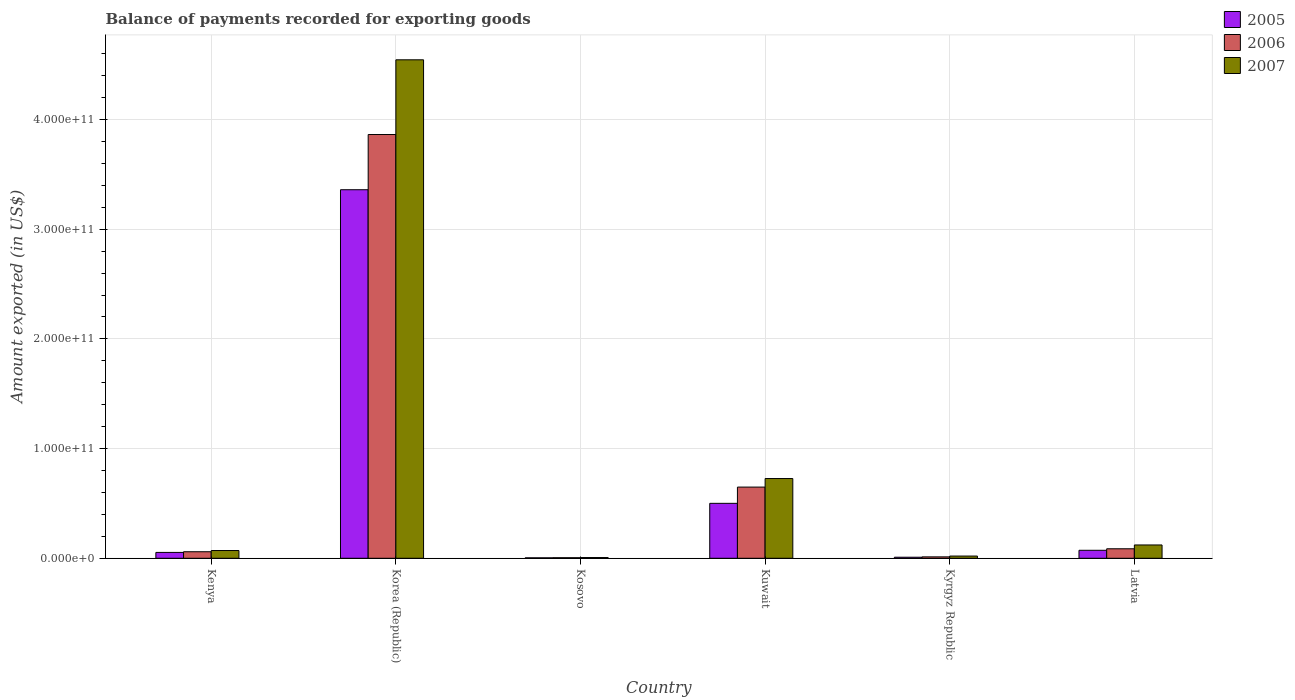How many groups of bars are there?
Your answer should be very brief. 6. How many bars are there on the 1st tick from the left?
Offer a very short reply. 3. What is the label of the 1st group of bars from the left?
Your answer should be compact. Kenya. In how many cases, is the number of bars for a given country not equal to the number of legend labels?
Offer a terse response. 0. What is the amount exported in 2006 in Kyrgyz Republic?
Keep it short and to the point. 1.28e+09. Across all countries, what is the maximum amount exported in 2007?
Your answer should be compact. 4.54e+11. Across all countries, what is the minimum amount exported in 2005?
Your answer should be compact. 4.13e+08. In which country was the amount exported in 2007 maximum?
Your answer should be very brief. Korea (Republic). In which country was the amount exported in 2006 minimum?
Your answer should be very brief. Kosovo. What is the total amount exported in 2006 in the graph?
Provide a succinct answer. 4.68e+11. What is the difference between the amount exported in 2006 in Kosovo and that in Kuwait?
Ensure brevity in your answer.  -6.44e+1. What is the difference between the amount exported in 2006 in Kuwait and the amount exported in 2007 in Korea (Republic)?
Provide a short and direct response. -3.90e+11. What is the average amount exported in 2005 per country?
Offer a terse response. 6.67e+1. What is the difference between the amount exported of/in 2005 and amount exported of/in 2006 in Kenya?
Provide a short and direct response. -6.04e+08. In how many countries, is the amount exported in 2006 greater than 40000000000 US$?
Make the answer very short. 2. What is the ratio of the amount exported in 2006 in Kenya to that in Kuwait?
Offer a very short reply. 0.09. Is the amount exported in 2006 in Kenya less than that in Latvia?
Your answer should be compact. Yes. What is the difference between the highest and the second highest amount exported in 2006?
Give a very brief answer. 3.21e+11. What is the difference between the highest and the lowest amount exported in 2005?
Make the answer very short. 3.36e+11. How many bars are there?
Make the answer very short. 18. How many countries are there in the graph?
Give a very brief answer. 6. What is the difference between two consecutive major ticks on the Y-axis?
Ensure brevity in your answer.  1.00e+11. Are the values on the major ticks of Y-axis written in scientific E-notation?
Your answer should be compact. Yes. Where does the legend appear in the graph?
Your response must be concise. Top right. How are the legend labels stacked?
Your response must be concise. Vertical. What is the title of the graph?
Your response must be concise. Balance of payments recorded for exporting goods. What is the label or title of the X-axis?
Your answer should be compact. Country. What is the label or title of the Y-axis?
Your response must be concise. Amount exported (in US$). What is the Amount exported (in US$) in 2005 in Kenya?
Offer a very short reply. 5.34e+09. What is the Amount exported (in US$) of 2006 in Kenya?
Ensure brevity in your answer.  5.95e+09. What is the Amount exported (in US$) of 2007 in Kenya?
Offer a terse response. 7.06e+09. What is the Amount exported (in US$) in 2005 in Korea (Republic)?
Your response must be concise. 3.36e+11. What is the Amount exported (in US$) of 2006 in Korea (Republic)?
Ensure brevity in your answer.  3.86e+11. What is the Amount exported (in US$) in 2007 in Korea (Republic)?
Give a very brief answer. 4.54e+11. What is the Amount exported (in US$) in 2005 in Kosovo?
Make the answer very short. 4.13e+08. What is the Amount exported (in US$) in 2006 in Kosovo?
Give a very brief answer. 5.15e+08. What is the Amount exported (in US$) of 2007 in Kosovo?
Your answer should be compact. 6.68e+08. What is the Amount exported (in US$) of 2005 in Kuwait?
Provide a succinct answer. 5.01e+1. What is the Amount exported (in US$) of 2006 in Kuwait?
Offer a very short reply. 6.49e+1. What is the Amount exported (in US$) in 2007 in Kuwait?
Your answer should be compact. 7.27e+1. What is the Amount exported (in US$) of 2005 in Kyrgyz Republic?
Provide a succinct answer. 9.46e+08. What is the Amount exported (in US$) of 2006 in Kyrgyz Republic?
Your response must be concise. 1.28e+09. What is the Amount exported (in US$) in 2007 in Kyrgyz Republic?
Give a very brief answer. 2.02e+09. What is the Amount exported (in US$) in 2005 in Latvia?
Offer a very short reply. 7.27e+09. What is the Amount exported (in US$) of 2006 in Latvia?
Offer a very short reply. 8.65e+09. What is the Amount exported (in US$) of 2007 in Latvia?
Offer a terse response. 1.21e+1. Across all countries, what is the maximum Amount exported (in US$) of 2005?
Provide a short and direct response. 3.36e+11. Across all countries, what is the maximum Amount exported (in US$) in 2006?
Your answer should be compact. 3.86e+11. Across all countries, what is the maximum Amount exported (in US$) of 2007?
Your answer should be compact. 4.54e+11. Across all countries, what is the minimum Amount exported (in US$) of 2005?
Your response must be concise. 4.13e+08. Across all countries, what is the minimum Amount exported (in US$) of 2006?
Make the answer very short. 5.15e+08. Across all countries, what is the minimum Amount exported (in US$) in 2007?
Your response must be concise. 6.68e+08. What is the total Amount exported (in US$) in 2005 in the graph?
Your response must be concise. 4.00e+11. What is the total Amount exported (in US$) in 2006 in the graph?
Provide a succinct answer. 4.68e+11. What is the total Amount exported (in US$) of 2007 in the graph?
Give a very brief answer. 5.49e+11. What is the difference between the Amount exported (in US$) of 2005 in Kenya and that in Korea (Republic)?
Offer a very short reply. -3.31e+11. What is the difference between the Amount exported (in US$) of 2006 in Kenya and that in Korea (Republic)?
Keep it short and to the point. -3.80e+11. What is the difference between the Amount exported (in US$) in 2007 in Kenya and that in Korea (Republic)?
Provide a short and direct response. -4.47e+11. What is the difference between the Amount exported (in US$) in 2005 in Kenya and that in Kosovo?
Make the answer very short. 4.93e+09. What is the difference between the Amount exported (in US$) in 2006 in Kenya and that in Kosovo?
Make the answer very short. 5.43e+09. What is the difference between the Amount exported (in US$) of 2007 in Kenya and that in Kosovo?
Ensure brevity in your answer.  6.39e+09. What is the difference between the Amount exported (in US$) of 2005 in Kenya and that in Kuwait?
Offer a very short reply. -4.47e+1. What is the difference between the Amount exported (in US$) in 2006 in Kenya and that in Kuwait?
Make the answer very short. -5.90e+1. What is the difference between the Amount exported (in US$) of 2007 in Kenya and that in Kuwait?
Your answer should be very brief. -6.56e+1. What is the difference between the Amount exported (in US$) in 2005 in Kenya and that in Kyrgyz Republic?
Provide a short and direct response. 4.40e+09. What is the difference between the Amount exported (in US$) in 2006 in Kenya and that in Kyrgyz Republic?
Give a very brief answer. 4.66e+09. What is the difference between the Amount exported (in US$) of 2007 in Kenya and that in Kyrgyz Republic?
Your response must be concise. 5.04e+09. What is the difference between the Amount exported (in US$) of 2005 in Kenya and that in Latvia?
Ensure brevity in your answer.  -1.93e+09. What is the difference between the Amount exported (in US$) of 2006 in Kenya and that in Latvia?
Make the answer very short. -2.71e+09. What is the difference between the Amount exported (in US$) of 2007 in Kenya and that in Latvia?
Your answer should be compact. -5.07e+09. What is the difference between the Amount exported (in US$) in 2005 in Korea (Republic) and that in Kosovo?
Your response must be concise. 3.36e+11. What is the difference between the Amount exported (in US$) of 2006 in Korea (Republic) and that in Kosovo?
Offer a terse response. 3.86e+11. What is the difference between the Amount exported (in US$) of 2007 in Korea (Republic) and that in Kosovo?
Offer a very short reply. 4.54e+11. What is the difference between the Amount exported (in US$) of 2005 in Korea (Republic) and that in Kuwait?
Provide a succinct answer. 2.86e+11. What is the difference between the Amount exported (in US$) of 2006 in Korea (Republic) and that in Kuwait?
Your response must be concise. 3.21e+11. What is the difference between the Amount exported (in US$) of 2007 in Korea (Republic) and that in Kuwait?
Make the answer very short. 3.82e+11. What is the difference between the Amount exported (in US$) of 2005 in Korea (Republic) and that in Kyrgyz Republic?
Provide a short and direct response. 3.35e+11. What is the difference between the Amount exported (in US$) in 2006 in Korea (Republic) and that in Kyrgyz Republic?
Your answer should be compact. 3.85e+11. What is the difference between the Amount exported (in US$) in 2007 in Korea (Republic) and that in Kyrgyz Republic?
Keep it short and to the point. 4.52e+11. What is the difference between the Amount exported (in US$) of 2005 in Korea (Republic) and that in Latvia?
Provide a short and direct response. 3.29e+11. What is the difference between the Amount exported (in US$) of 2006 in Korea (Republic) and that in Latvia?
Provide a short and direct response. 3.78e+11. What is the difference between the Amount exported (in US$) in 2007 in Korea (Republic) and that in Latvia?
Provide a succinct answer. 4.42e+11. What is the difference between the Amount exported (in US$) in 2005 in Kosovo and that in Kuwait?
Provide a succinct answer. -4.97e+1. What is the difference between the Amount exported (in US$) of 2006 in Kosovo and that in Kuwait?
Offer a very short reply. -6.44e+1. What is the difference between the Amount exported (in US$) of 2007 in Kosovo and that in Kuwait?
Offer a terse response. -7.20e+1. What is the difference between the Amount exported (in US$) of 2005 in Kosovo and that in Kyrgyz Republic?
Offer a terse response. -5.33e+08. What is the difference between the Amount exported (in US$) of 2006 in Kosovo and that in Kyrgyz Republic?
Keep it short and to the point. -7.70e+08. What is the difference between the Amount exported (in US$) in 2007 in Kosovo and that in Kyrgyz Republic?
Offer a terse response. -1.35e+09. What is the difference between the Amount exported (in US$) of 2005 in Kosovo and that in Latvia?
Provide a succinct answer. -6.86e+09. What is the difference between the Amount exported (in US$) of 2006 in Kosovo and that in Latvia?
Provide a succinct answer. -8.14e+09. What is the difference between the Amount exported (in US$) in 2007 in Kosovo and that in Latvia?
Provide a short and direct response. -1.15e+1. What is the difference between the Amount exported (in US$) of 2005 in Kuwait and that in Kyrgyz Republic?
Keep it short and to the point. 4.91e+1. What is the difference between the Amount exported (in US$) of 2006 in Kuwait and that in Kyrgyz Republic?
Ensure brevity in your answer.  6.36e+1. What is the difference between the Amount exported (in US$) of 2007 in Kuwait and that in Kyrgyz Republic?
Provide a succinct answer. 7.07e+1. What is the difference between the Amount exported (in US$) of 2005 in Kuwait and that in Latvia?
Keep it short and to the point. 4.28e+1. What is the difference between the Amount exported (in US$) in 2006 in Kuwait and that in Latvia?
Your answer should be very brief. 5.62e+1. What is the difference between the Amount exported (in US$) of 2007 in Kuwait and that in Latvia?
Make the answer very short. 6.06e+1. What is the difference between the Amount exported (in US$) in 2005 in Kyrgyz Republic and that in Latvia?
Keep it short and to the point. -6.33e+09. What is the difference between the Amount exported (in US$) in 2006 in Kyrgyz Republic and that in Latvia?
Provide a succinct answer. -7.37e+09. What is the difference between the Amount exported (in US$) in 2007 in Kyrgyz Republic and that in Latvia?
Provide a short and direct response. -1.01e+1. What is the difference between the Amount exported (in US$) of 2005 in Kenya and the Amount exported (in US$) of 2006 in Korea (Republic)?
Keep it short and to the point. -3.81e+11. What is the difference between the Amount exported (in US$) of 2005 in Kenya and the Amount exported (in US$) of 2007 in Korea (Republic)?
Keep it short and to the point. -4.49e+11. What is the difference between the Amount exported (in US$) of 2006 in Kenya and the Amount exported (in US$) of 2007 in Korea (Republic)?
Keep it short and to the point. -4.48e+11. What is the difference between the Amount exported (in US$) of 2005 in Kenya and the Amount exported (in US$) of 2006 in Kosovo?
Offer a very short reply. 4.83e+09. What is the difference between the Amount exported (in US$) of 2005 in Kenya and the Amount exported (in US$) of 2007 in Kosovo?
Give a very brief answer. 4.67e+09. What is the difference between the Amount exported (in US$) in 2006 in Kenya and the Amount exported (in US$) in 2007 in Kosovo?
Provide a succinct answer. 5.28e+09. What is the difference between the Amount exported (in US$) of 2005 in Kenya and the Amount exported (in US$) of 2006 in Kuwait?
Keep it short and to the point. -5.96e+1. What is the difference between the Amount exported (in US$) in 2005 in Kenya and the Amount exported (in US$) in 2007 in Kuwait?
Your response must be concise. -6.74e+1. What is the difference between the Amount exported (in US$) of 2006 in Kenya and the Amount exported (in US$) of 2007 in Kuwait?
Your answer should be compact. -6.67e+1. What is the difference between the Amount exported (in US$) of 2005 in Kenya and the Amount exported (in US$) of 2006 in Kyrgyz Republic?
Provide a short and direct response. 4.06e+09. What is the difference between the Amount exported (in US$) of 2005 in Kenya and the Amount exported (in US$) of 2007 in Kyrgyz Republic?
Make the answer very short. 3.32e+09. What is the difference between the Amount exported (in US$) in 2006 in Kenya and the Amount exported (in US$) in 2007 in Kyrgyz Republic?
Provide a short and direct response. 3.92e+09. What is the difference between the Amount exported (in US$) in 2005 in Kenya and the Amount exported (in US$) in 2006 in Latvia?
Provide a succinct answer. -3.31e+09. What is the difference between the Amount exported (in US$) in 2005 in Kenya and the Amount exported (in US$) in 2007 in Latvia?
Give a very brief answer. -6.80e+09. What is the difference between the Amount exported (in US$) in 2006 in Kenya and the Amount exported (in US$) in 2007 in Latvia?
Offer a terse response. -6.19e+09. What is the difference between the Amount exported (in US$) of 2005 in Korea (Republic) and the Amount exported (in US$) of 2006 in Kosovo?
Your answer should be compact. 3.35e+11. What is the difference between the Amount exported (in US$) of 2005 in Korea (Republic) and the Amount exported (in US$) of 2007 in Kosovo?
Offer a very short reply. 3.35e+11. What is the difference between the Amount exported (in US$) of 2006 in Korea (Republic) and the Amount exported (in US$) of 2007 in Kosovo?
Make the answer very short. 3.86e+11. What is the difference between the Amount exported (in US$) of 2005 in Korea (Republic) and the Amount exported (in US$) of 2006 in Kuwait?
Provide a short and direct response. 2.71e+11. What is the difference between the Amount exported (in US$) in 2005 in Korea (Republic) and the Amount exported (in US$) in 2007 in Kuwait?
Your response must be concise. 2.63e+11. What is the difference between the Amount exported (in US$) of 2006 in Korea (Republic) and the Amount exported (in US$) of 2007 in Kuwait?
Keep it short and to the point. 3.14e+11. What is the difference between the Amount exported (in US$) of 2005 in Korea (Republic) and the Amount exported (in US$) of 2006 in Kyrgyz Republic?
Your answer should be very brief. 3.35e+11. What is the difference between the Amount exported (in US$) in 2005 in Korea (Republic) and the Amount exported (in US$) in 2007 in Kyrgyz Republic?
Provide a short and direct response. 3.34e+11. What is the difference between the Amount exported (in US$) of 2006 in Korea (Republic) and the Amount exported (in US$) of 2007 in Kyrgyz Republic?
Your response must be concise. 3.84e+11. What is the difference between the Amount exported (in US$) of 2005 in Korea (Republic) and the Amount exported (in US$) of 2006 in Latvia?
Ensure brevity in your answer.  3.27e+11. What is the difference between the Amount exported (in US$) of 2005 in Korea (Republic) and the Amount exported (in US$) of 2007 in Latvia?
Keep it short and to the point. 3.24e+11. What is the difference between the Amount exported (in US$) of 2006 in Korea (Republic) and the Amount exported (in US$) of 2007 in Latvia?
Provide a succinct answer. 3.74e+11. What is the difference between the Amount exported (in US$) of 2005 in Kosovo and the Amount exported (in US$) of 2006 in Kuwait?
Make the answer very short. -6.45e+1. What is the difference between the Amount exported (in US$) in 2005 in Kosovo and the Amount exported (in US$) in 2007 in Kuwait?
Your response must be concise. -7.23e+1. What is the difference between the Amount exported (in US$) in 2006 in Kosovo and the Amount exported (in US$) in 2007 in Kuwait?
Offer a terse response. -7.22e+1. What is the difference between the Amount exported (in US$) in 2005 in Kosovo and the Amount exported (in US$) in 2006 in Kyrgyz Republic?
Provide a short and direct response. -8.72e+08. What is the difference between the Amount exported (in US$) in 2005 in Kosovo and the Amount exported (in US$) in 2007 in Kyrgyz Republic?
Offer a terse response. -1.61e+09. What is the difference between the Amount exported (in US$) of 2006 in Kosovo and the Amount exported (in US$) of 2007 in Kyrgyz Republic?
Give a very brief answer. -1.51e+09. What is the difference between the Amount exported (in US$) of 2005 in Kosovo and the Amount exported (in US$) of 2006 in Latvia?
Provide a succinct answer. -8.24e+09. What is the difference between the Amount exported (in US$) in 2005 in Kosovo and the Amount exported (in US$) in 2007 in Latvia?
Provide a succinct answer. -1.17e+1. What is the difference between the Amount exported (in US$) of 2006 in Kosovo and the Amount exported (in US$) of 2007 in Latvia?
Give a very brief answer. -1.16e+1. What is the difference between the Amount exported (in US$) in 2005 in Kuwait and the Amount exported (in US$) in 2006 in Kyrgyz Republic?
Your answer should be very brief. 4.88e+1. What is the difference between the Amount exported (in US$) of 2005 in Kuwait and the Amount exported (in US$) of 2007 in Kyrgyz Republic?
Offer a very short reply. 4.81e+1. What is the difference between the Amount exported (in US$) of 2006 in Kuwait and the Amount exported (in US$) of 2007 in Kyrgyz Republic?
Ensure brevity in your answer.  6.29e+1. What is the difference between the Amount exported (in US$) in 2005 in Kuwait and the Amount exported (in US$) in 2006 in Latvia?
Provide a short and direct response. 4.14e+1. What is the difference between the Amount exported (in US$) in 2005 in Kuwait and the Amount exported (in US$) in 2007 in Latvia?
Ensure brevity in your answer.  3.79e+1. What is the difference between the Amount exported (in US$) of 2006 in Kuwait and the Amount exported (in US$) of 2007 in Latvia?
Offer a terse response. 5.28e+1. What is the difference between the Amount exported (in US$) in 2005 in Kyrgyz Republic and the Amount exported (in US$) in 2006 in Latvia?
Offer a terse response. -7.71e+09. What is the difference between the Amount exported (in US$) in 2005 in Kyrgyz Republic and the Amount exported (in US$) in 2007 in Latvia?
Your response must be concise. -1.12e+1. What is the difference between the Amount exported (in US$) of 2006 in Kyrgyz Republic and the Amount exported (in US$) of 2007 in Latvia?
Offer a very short reply. -1.09e+1. What is the average Amount exported (in US$) of 2005 per country?
Give a very brief answer. 6.67e+1. What is the average Amount exported (in US$) in 2006 per country?
Provide a succinct answer. 7.79e+1. What is the average Amount exported (in US$) in 2007 per country?
Ensure brevity in your answer.  9.15e+1. What is the difference between the Amount exported (in US$) in 2005 and Amount exported (in US$) in 2006 in Kenya?
Provide a succinct answer. -6.04e+08. What is the difference between the Amount exported (in US$) in 2005 and Amount exported (in US$) in 2007 in Kenya?
Give a very brief answer. -1.72e+09. What is the difference between the Amount exported (in US$) of 2006 and Amount exported (in US$) of 2007 in Kenya?
Make the answer very short. -1.12e+09. What is the difference between the Amount exported (in US$) of 2005 and Amount exported (in US$) of 2006 in Korea (Republic)?
Your answer should be very brief. -5.03e+1. What is the difference between the Amount exported (in US$) of 2005 and Amount exported (in US$) of 2007 in Korea (Republic)?
Your answer should be very brief. -1.18e+11. What is the difference between the Amount exported (in US$) of 2006 and Amount exported (in US$) of 2007 in Korea (Republic)?
Your answer should be compact. -6.81e+1. What is the difference between the Amount exported (in US$) of 2005 and Amount exported (in US$) of 2006 in Kosovo?
Provide a short and direct response. -1.02e+08. What is the difference between the Amount exported (in US$) of 2005 and Amount exported (in US$) of 2007 in Kosovo?
Provide a short and direct response. -2.55e+08. What is the difference between the Amount exported (in US$) of 2006 and Amount exported (in US$) of 2007 in Kosovo?
Your answer should be very brief. -1.53e+08. What is the difference between the Amount exported (in US$) in 2005 and Amount exported (in US$) in 2006 in Kuwait?
Give a very brief answer. -1.48e+1. What is the difference between the Amount exported (in US$) in 2005 and Amount exported (in US$) in 2007 in Kuwait?
Ensure brevity in your answer.  -2.26e+1. What is the difference between the Amount exported (in US$) in 2006 and Amount exported (in US$) in 2007 in Kuwait?
Make the answer very short. -7.80e+09. What is the difference between the Amount exported (in US$) in 2005 and Amount exported (in US$) in 2006 in Kyrgyz Republic?
Ensure brevity in your answer.  -3.38e+08. What is the difference between the Amount exported (in US$) of 2005 and Amount exported (in US$) of 2007 in Kyrgyz Republic?
Offer a terse response. -1.08e+09. What is the difference between the Amount exported (in US$) of 2006 and Amount exported (in US$) of 2007 in Kyrgyz Republic?
Keep it short and to the point. -7.38e+08. What is the difference between the Amount exported (in US$) in 2005 and Amount exported (in US$) in 2006 in Latvia?
Ensure brevity in your answer.  -1.38e+09. What is the difference between the Amount exported (in US$) of 2005 and Amount exported (in US$) of 2007 in Latvia?
Your answer should be compact. -4.86e+09. What is the difference between the Amount exported (in US$) in 2006 and Amount exported (in US$) in 2007 in Latvia?
Your response must be concise. -3.48e+09. What is the ratio of the Amount exported (in US$) in 2005 in Kenya to that in Korea (Republic)?
Ensure brevity in your answer.  0.02. What is the ratio of the Amount exported (in US$) of 2006 in Kenya to that in Korea (Republic)?
Offer a very short reply. 0.02. What is the ratio of the Amount exported (in US$) of 2007 in Kenya to that in Korea (Republic)?
Your response must be concise. 0.02. What is the ratio of the Amount exported (in US$) of 2005 in Kenya to that in Kosovo?
Your answer should be very brief. 12.94. What is the ratio of the Amount exported (in US$) of 2006 in Kenya to that in Kosovo?
Provide a succinct answer. 11.55. What is the ratio of the Amount exported (in US$) of 2007 in Kenya to that in Kosovo?
Provide a short and direct response. 10.57. What is the ratio of the Amount exported (in US$) in 2005 in Kenya to that in Kuwait?
Make the answer very short. 0.11. What is the ratio of the Amount exported (in US$) in 2006 in Kenya to that in Kuwait?
Keep it short and to the point. 0.09. What is the ratio of the Amount exported (in US$) in 2007 in Kenya to that in Kuwait?
Ensure brevity in your answer.  0.1. What is the ratio of the Amount exported (in US$) of 2005 in Kenya to that in Kyrgyz Republic?
Your response must be concise. 5.65. What is the ratio of the Amount exported (in US$) of 2006 in Kenya to that in Kyrgyz Republic?
Offer a terse response. 4.63. What is the ratio of the Amount exported (in US$) of 2007 in Kenya to that in Kyrgyz Republic?
Provide a succinct answer. 3.49. What is the ratio of the Amount exported (in US$) of 2005 in Kenya to that in Latvia?
Ensure brevity in your answer.  0.73. What is the ratio of the Amount exported (in US$) in 2006 in Kenya to that in Latvia?
Provide a succinct answer. 0.69. What is the ratio of the Amount exported (in US$) in 2007 in Kenya to that in Latvia?
Offer a terse response. 0.58. What is the ratio of the Amount exported (in US$) of 2005 in Korea (Republic) to that in Kosovo?
Provide a short and direct response. 813.87. What is the ratio of the Amount exported (in US$) of 2006 in Korea (Republic) to that in Kosovo?
Offer a terse response. 750.35. What is the ratio of the Amount exported (in US$) of 2007 in Korea (Republic) to that in Kosovo?
Ensure brevity in your answer.  680.25. What is the ratio of the Amount exported (in US$) in 2005 in Korea (Republic) to that in Kuwait?
Keep it short and to the point. 6.71. What is the ratio of the Amount exported (in US$) in 2006 in Korea (Republic) to that in Kuwait?
Offer a very short reply. 5.95. What is the ratio of the Amount exported (in US$) in 2007 in Korea (Republic) to that in Kuwait?
Offer a terse response. 6.25. What is the ratio of the Amount exported (in US$) in 2005 in Korea (Republic) to that in Kyrgyz Republic?
Ensure brevity in your answer.  355.07. What is the ratio of the Amount exported (in US$) in 2006 in Korea (Republic) to that in Kyrgyz Republic?
Offer a very short reply. 300.7. What is the ratio of the Amount exported (in US$) in 2007 in Korea (Republic) to that in Kyrgyz Republic?
Your answer should be compact. 224.68. What is the ratio of the Amount exported (in US$) in 2005 in Korea (Republic) to that in Latvia?
Provide a succinct answer. 46.2. What is the ratio of the Amount exported (in US$) of 2006 in Korea (Republic) to that in Latvia?
Offer a very short reply. 44.64. What is the ratio of the Amount exported (in US$) of 2007 in Korea (Republic) to that in Latvia?
Keep it short and to the point. 37.44. What is the ratio of the Amount exported (in US$) of 2005 in Kosovo to that in Kuwait?
Make the answer very short. 0.01. What is the ratio of the Amount exported (in US$) in 2006 in Kosovo to that in Kuwait?
Provide a succinct answer. 0.01. What is the ratio of the Amount exported (in US$) in 2007 in Kosovo to that in Kuwait?
Give a very brief answer. 0.01. What is the ratio of the Amount exported (in US$) of 2005 in Kosovo to that in Kyrgyz Republic?
Your answer should be very brief. 0.44. What is the ratio of the Amount exported (in US$) of 2006 in Kosovo to that in Kyrgyz Republic?
Your answer should be very brief. 0.4. What is the ratio of the Amount exported (in US$) in 2007 in Kosovo to that in Kyrgyz Republic?
Ensure brevity in your answer.  0.33. What is the ratio of the Amount exported (in US$) of 2005 in Kosovo to that in Latvia?
Keep it short and to the point. 0.06. What is the ratio of the Amount exported (in US$) of 2006 in Kosovo to that in Latvia?
Your answer should be very brief. 0.06. What is the ratio of the Amount exported (in US$) of 2007 in Kosovo to that in Latvia?
Make the answer very short. 0.06. What is the ratio of the Amount exported (in US$) of 2005 in Kuwait to that in Kyrgyz Republic?
Ensure brevity in your answer.  52.92. What is the ratio of the Amount exported (in US$) of 2006 in Kuwait to that in Kyrgyz Republic?
Provide a succinct answer. 50.51. What is the ratio of the Amount exported (in US$) of 2007 in Kuwait to that in Kyrgyz Republic?
Your response must be concise. 35.94. What is the ratio of the Amount exported (in US$) in 2005 in Kuwait to that in Latvia?
Offer a terse response. 6.89. What is the ratio of the Amount exported (in US$) of 2006 in Kuwait to that in Latvia?
Ensure brevity in your answer.  7.5. What is the ratio of the Amount exported (in US$) of 2007 in Kuwait to that in Latvia?
Your answer should be very brief. 5.99. What is the ratio of the Amount exported (in US$) of 2005 in Kyrgyz Republic to that in Latvia?
Make the answer very short. 0.13. What is the ratio of the Amount exported (in US$) of 2006 in Kyrgyz Republic to that in Latvia?
Keep it short and to the point. 0.15. What is the ratio of the Amount exported (in US$) in 2007 in Kyrgyz Republic to that in Latvia?
Ensure brevity in your answer.  0.17. What is the difference between the highest and the second highest Amount exported (in US$) in 2005?
Your answer should be very brief. 2.86e+11. What is the difference between the highest and the second highest Amount exported (in US$) of 2006?
Give a very brief answer. 3.21e+11. What is the difference between the highest and the second highest Amount exported (in US$) of 2007?
Your response must be concise. 3.82e+11. What is the difference between the highest and the lowest Amount exported (in US$) of 2005?
Give a very brief answer. 3.36e+11. What is the difference between the highest and the lowest Amount exported (in US$) in 2006?
Ensure brevity in your answer.  3.86e+11. What is the difference between the highest and the lowest Amount exported (in US$) in 2007?
Make the answer very short. 4.54e+11. 